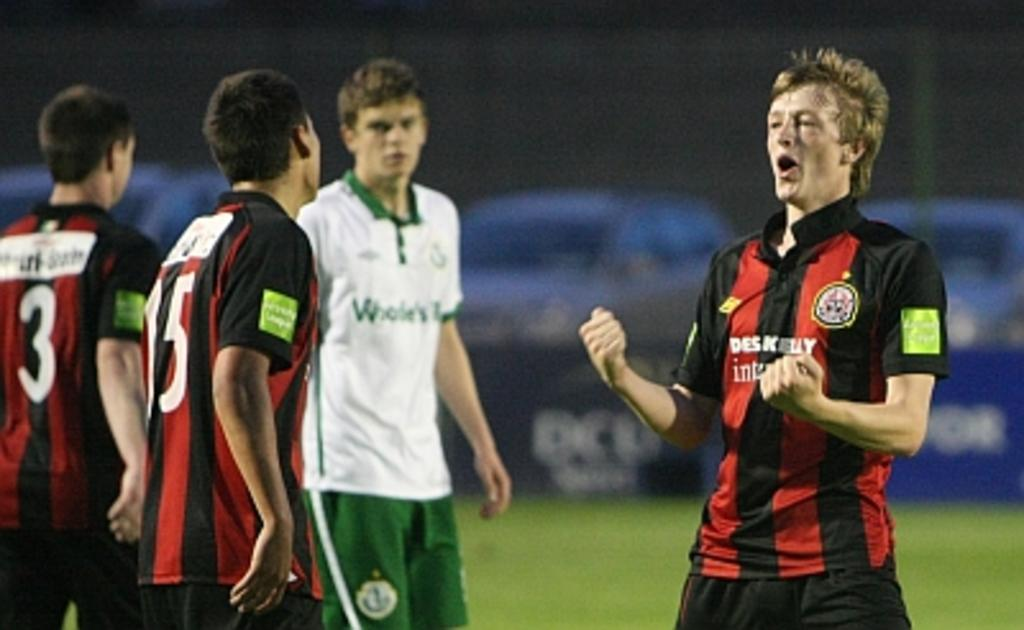<image>
Write a terse but informative summary of the picture. A guy in a jersey with the number 3 on it is on a field with other players. 